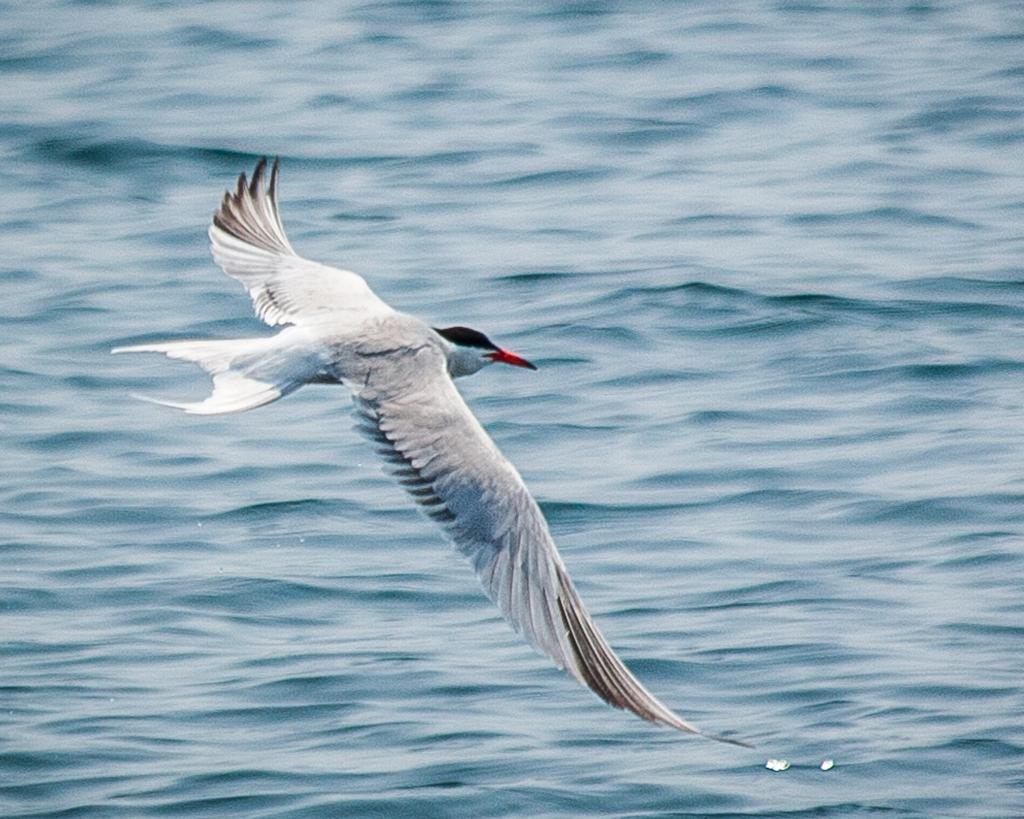What type of animal can be seen in the image? There is a bird in the image. Can you describe the bird's appearance? The bird has multiple colors, including white, grey, red, brown, and black. What is the bird doing in the image? The bird is flying in the air. What can be seen in the background of the image? There is a sky visible in the background of the image. What type of lumber is the bird using to build its nest in the image? There is no nest or lumber present in the image; it features a bird flying in the air. How does the bird's cushion help it fly in the image? There is no cushion present in the image; the bird is flying without any visible assistance. 